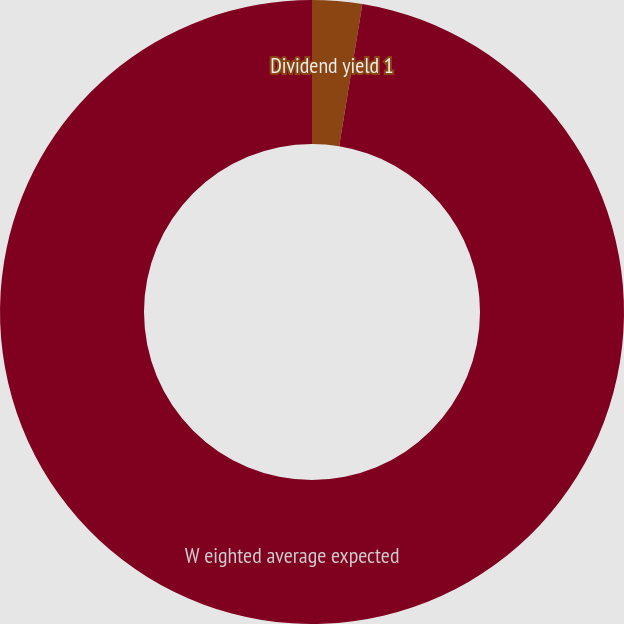<chart> <loc_0><loc_0><loc_500><loc_500><pie_chart><fcel>Dividend yield 1<fcel>W eighted average expected<nl><fcel>2.58%<fcel>97.42%<nl></chart> 